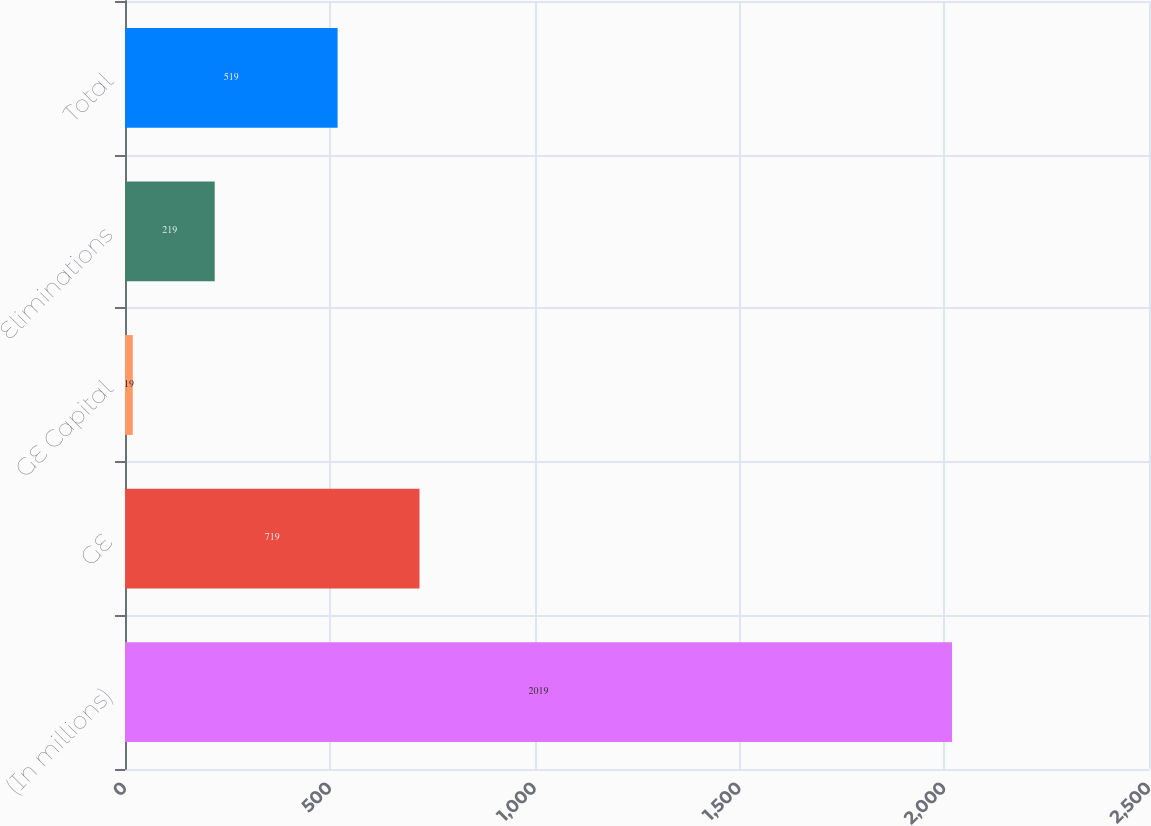Convert chart to OTSL. <chart><loc_0><loc_0><loc_500><loc_500><bar_chart><fcel>(In millions)<fcel>GE<fcel>GE Capital<fcel>Eliminations<fcel>Total<nl><fcel>2019<fcel>719<fcel>19<fcel>219<fcel>519<nl></chart> 